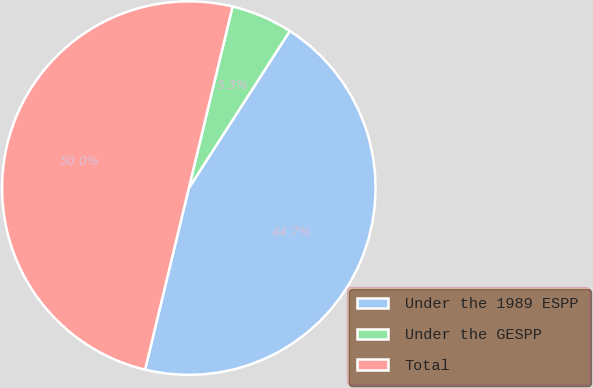Convert chart to OTSL. <chart><loc_0><loc_0><loc_500><loc_500><pie_chart><fcel>Under the 1989 ESPP<fcel>Under the GESPP<fcel>Total<nl><fcel>44.67%<fcel>5.33%<fcel>50.0%<nl></chart> 